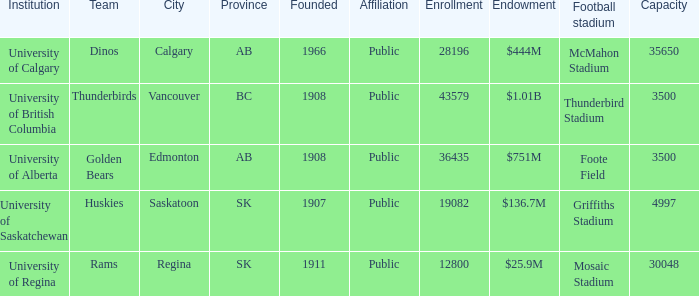How many institutions are shown for the football stadium of mosaic stadium? 1.0. 